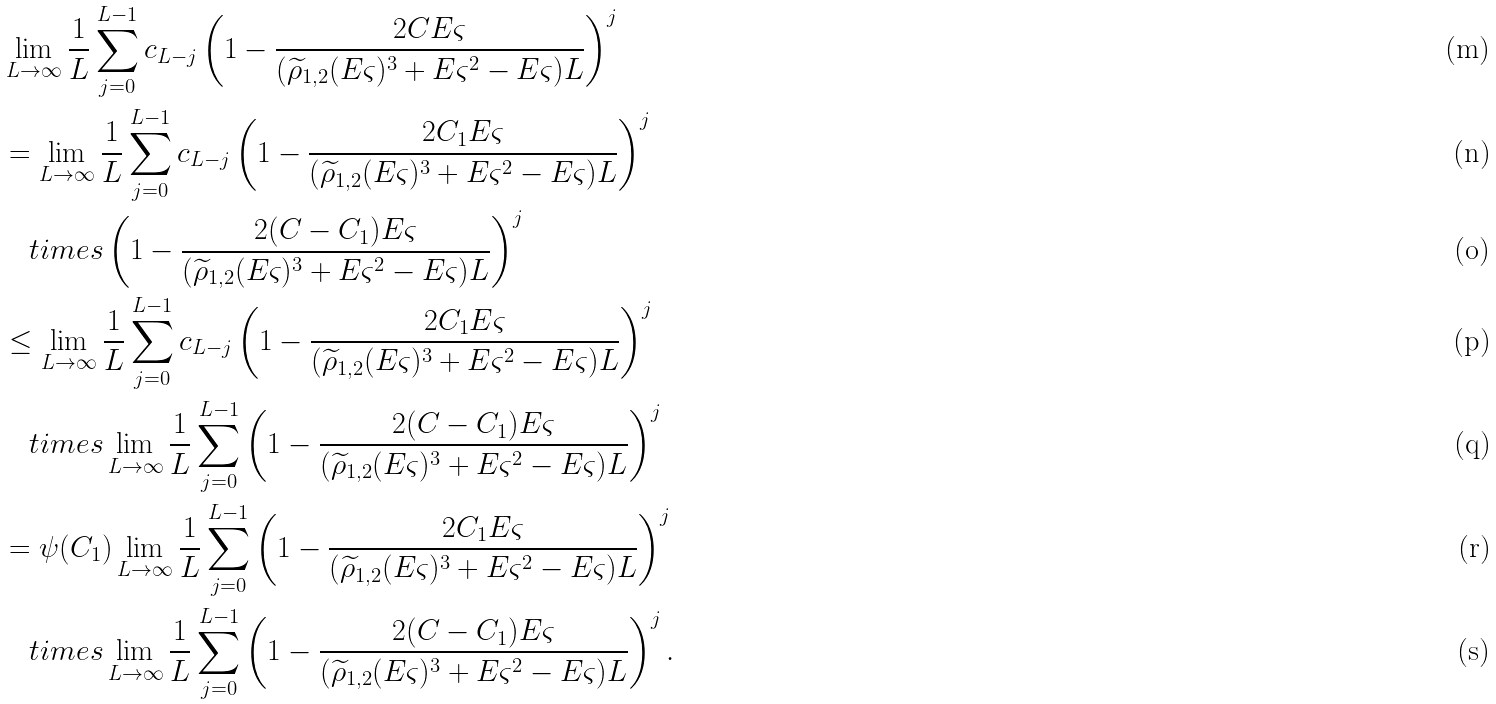<formula> <loc_0><loc_0><loc_500><loc_500>& \lim _ { L \to \infty } \frac { 1 } { L } \sum _ { j = 0 } ^ { L - 1 } c _ { L - j } \left ( 1 - \frac { 2 C E \varsigma } { ( \widetilde { \rho } _ { 1 , 2 } ( E \varsigma ) ^ { 3 } + E \varsigma ^ { 2 } - E \varsigma ) L } \right ) ^ { j } \\ & = \lim _ { L \to \infty } \frac { 1 } { L } \sum _ { j = 0 } ^ { L - 1 } c _ { L - j } \left ( 1 - \frac { 2 C _ { 1 } E \varsigma } { ( \widetilde { \rho } _ { 1 , 2 } ( E \varsigma ) ^ { 3 } + E \varsigma ^ { 2 } - E \varsigma ) L } \right ) ^ { j } \\ & \quad t i m e s \left ( 1 - \frac { 2 ( C - C _ { 1 } ) E \varsigma } { ( \widetilde { \rho } _ { 1 , 2 } ( E \varsigma ) ^ { 3 } + E \varsigma ^ { 2 } - E \varsigma ) L } \right ) ^ { j } \\ & \leq \lim _ { L \to \infty } \frac { 1 } { L } \sum _ { j = 0 } ^ { L - 1 } c _ { L - j } \left ( 1 - \frac { 2 C _ { 1 } E \varsigma } { ( \widetilde { \rho } _ { 1 , 2 } ( E \varsigma ) ^ { 3 } + E \varsigma ^ { 2 } - E \varsigma ) L } \right ) ^ { j } \\ & \quad t i m e s \lim _ { L \to \infty } \frac { 1 } { L } \sum _ { j = 0 } ^ { L - 1 } \left ( 1 - \frac { 2 ( C - C _ { 1 } ) E \varsigma } { ( \widetilde { \rho } _ { 1 , 2 } ( E \varsigma ) ^ { 3 } + E \varsigma ^ { 2 } - E \varsigma ) L } \right ) ^ { j } \\ & = \psi ( C _ { 1 } ) \lim _ { L \to \infty } \frac { 1 } { L } \sum _ { j = 0 } ^ { L - 1 } \left ( 1 - \frac { 2 C _ { 1 } E \varsigma } { ( \widetilde { \rho } _ { 1 , 2 } ( E \varsigma ) ^ { 3 } + E \varsigma ^ { 2 } - E \varsigma ) L } \right ) ^ { j } \\ & \quad t i m e s \lim _ { L \to \infty } \frac { 1 } { L } \sum _ { j = 0 } ^ { L - 1 } \left ( 1 - \frac { 2 ( C - C _ { 1 } ) E \varsigma } { ( \widetilde { \rho } _ { 1 , 2 } ( E \varsigma ) ^ { 3 } + E \varsigma ^ { 2 } - E \varsigma ) L } \right ) ^ { j } .</formula> 